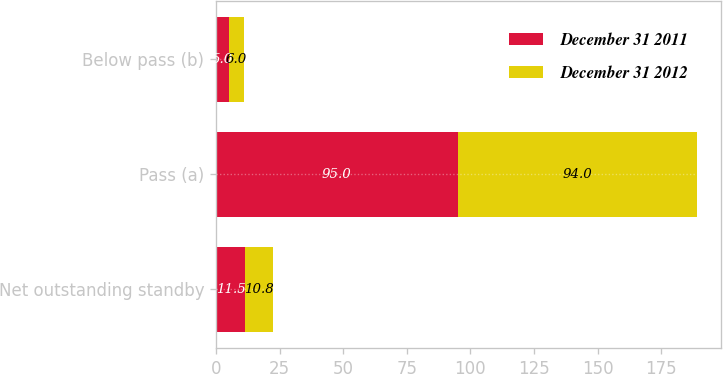<chart> <loc_0><loc_0><loc_500><loc_500><stacked_bar_chart><ecel><fcel>Net outstanding standby<fcel>Pass (a)<fcel>Below pass (b)<nl><fcel>December 31 2011<fcel>11.5<fcel>95<fcel>5<nl><fcel>December 31 2012<fcel>10.8<fcel>94<fcel>6<nl></chart> 